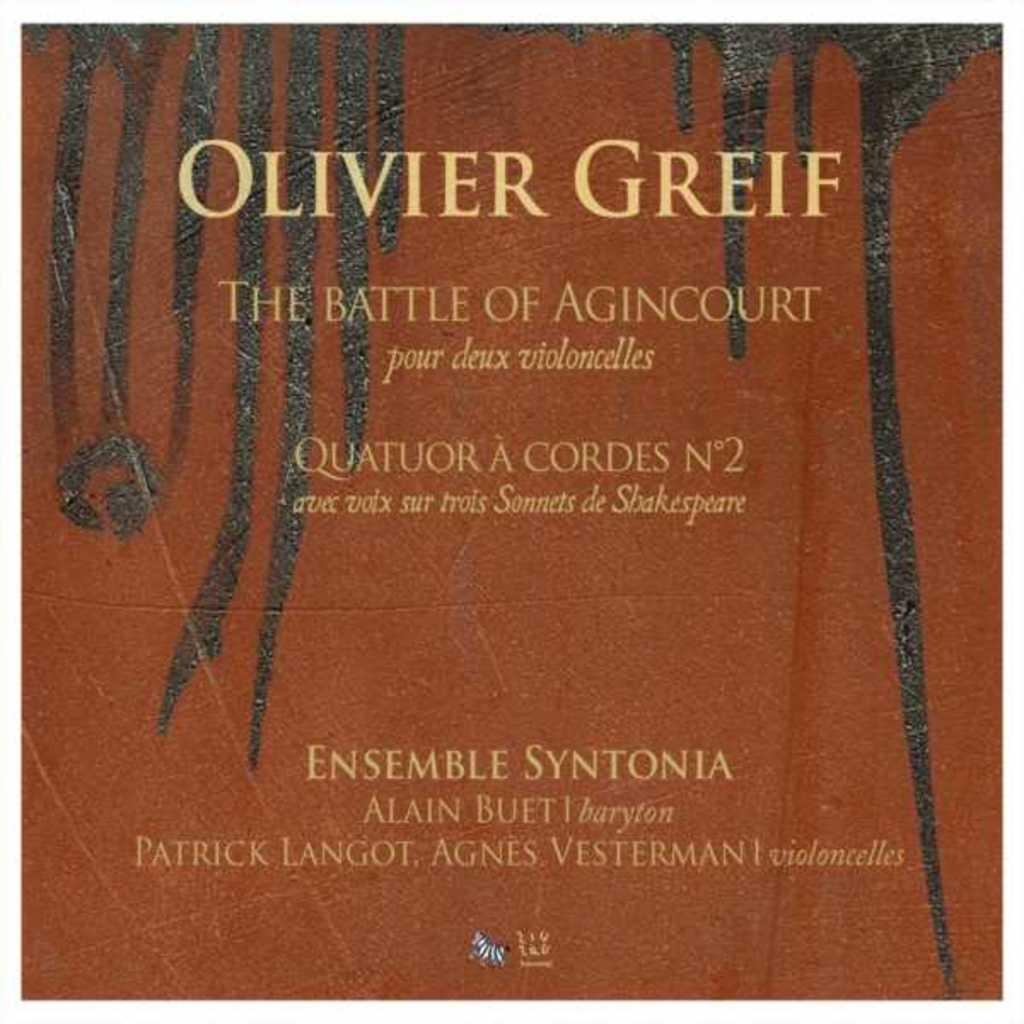<image>
Offer a succinct explanation of the picture presented. An album of Olivier Greif's The Battle of Agincourt 